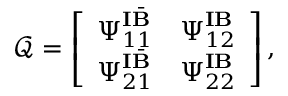Convert formula to latex. <formula><loc_0><loc_0><loc_500><loc_500>\mathcal { Q } = \left [ \begin{array} { l l } { \Psi _ { 1 1 } ^ { I \bar { B } } } & { \Psi _ { 1 2 } ^ { I B } } \\ { \Psi _ { 2 1 } ^ { I \bar { B } } } & { \Psi _ { 2 2 } ^ { I B } } \end{array} \right ] ,</formula> 